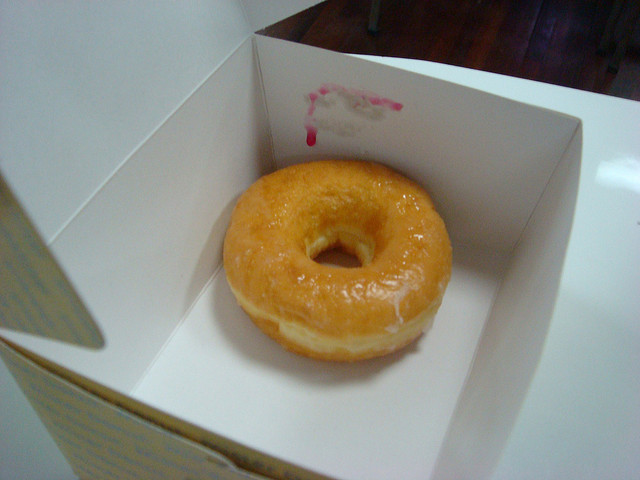What flavor do you think this donut might be? The donut in the image likely has a sweet vanilla flavor, indicated by its glossy, sugary glaze which is typical of a classic glazed donut. 